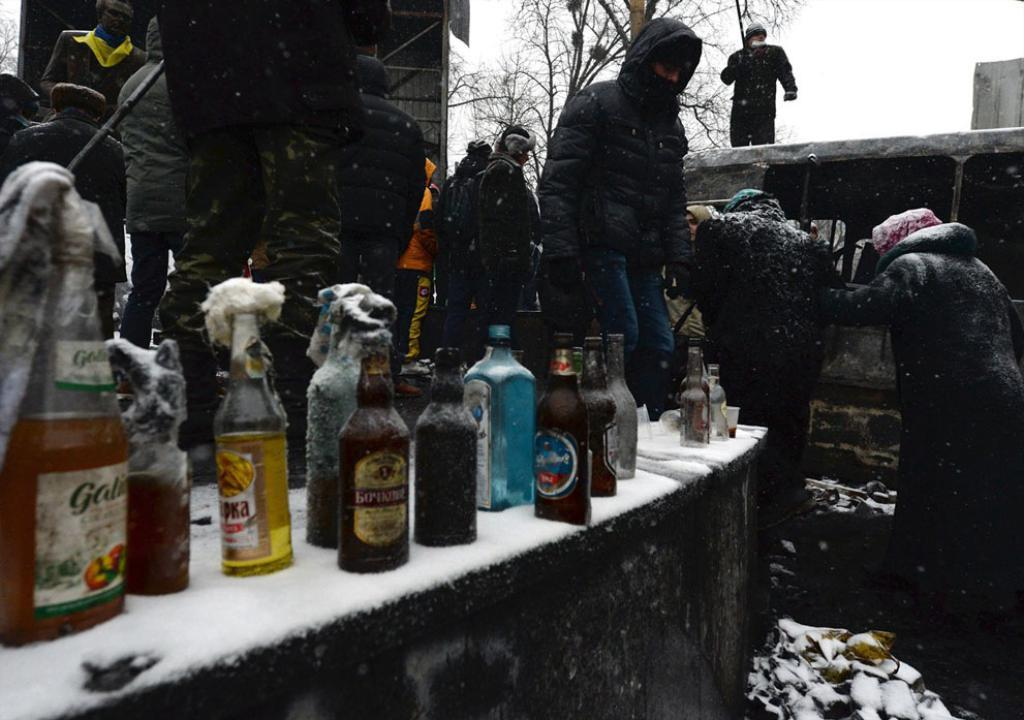What type of bottles are visible in the image? There are wine bottles in the image. Where are the wine bottles placed? The wine bottles are kept on a surface. Can you describe the people in the background of the image? There is a group of people standing in the background of the image. What type of seed is being planted by the goose in the image? There is no goose or seed present in the image; it only features wine bottles and a group of people in the background. 